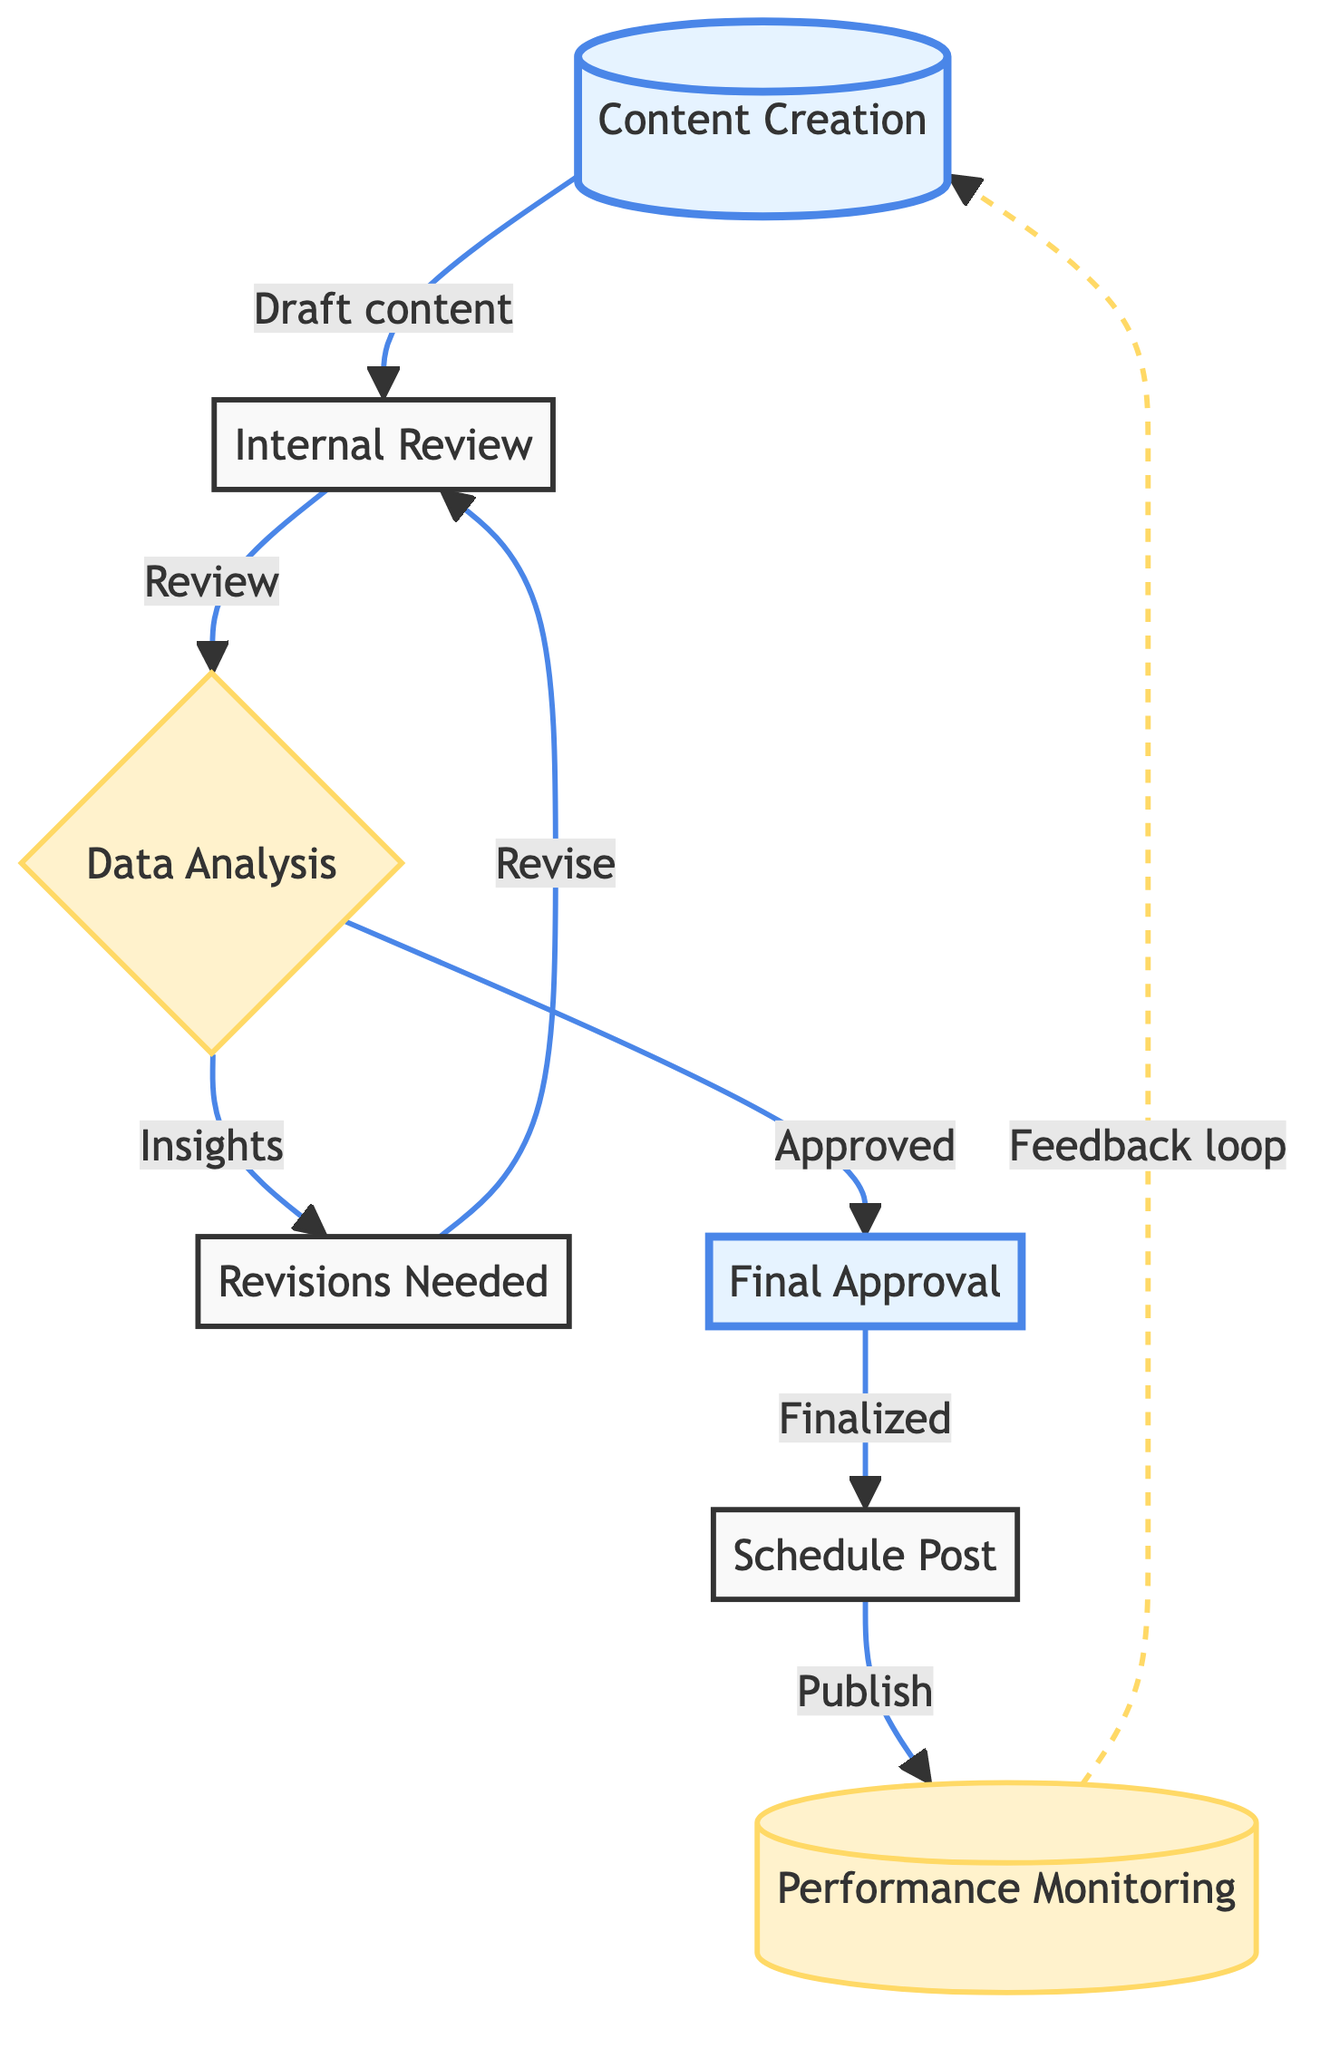What is the first step in the content approval process? The first step detailed in the diagram is "Content Creation," where the social media manager drafts the post content based on the marketing strategy.
Answer: Content Creation How many nodes are there in the flow chart? The flow chart features a total of seven nodes, representing different stages of the content approval process.
Answer: 7 What comes after "Internal Review"? After "Internal Review," the next step is "Data Analysis," where the social media manager analyzes past engagement metrics to inform adjustments.
Answer: Data Analysis Which step requires feedback and revisions? The step labeled "Revisions Needed" indicates the need for feedback and further revisions to the content drafted.
Answer: Revisions Needed What is the last step of the process? The final step in the process, as per the diagram, is "Performance Monitoring," where the post's performance is monitored and metrics are collected for future analysis.
Answer: Performance Monitoring Which node is highlighted as requiring final review? The "Final Approval" node is specifically highlighted as the stage where the brand manager reviews and approves the finalized post.
Answer: Final Approval What happens after "Final Approval"? Following "Final Approval," the next step is "Schedule Post," which involves scheduling the approved content for publishing on social media platforms.
Answer: Schedule Post What type of relationship exists between "Performance Monitoring" and "Content Creation"? A feedback loop relationship exists between "Performance Monitoring" and "Content Creation," indicating that performance feedback can inform future content creation.
Answer: Feedback loop Which steps involve the social media manager directly? The steps that involve the social media manager directly are "Content Creation," "Data Analysis," and "Performance Monitoring."
Answer: Content Creation, Data Analysis, Performance Monitoring 